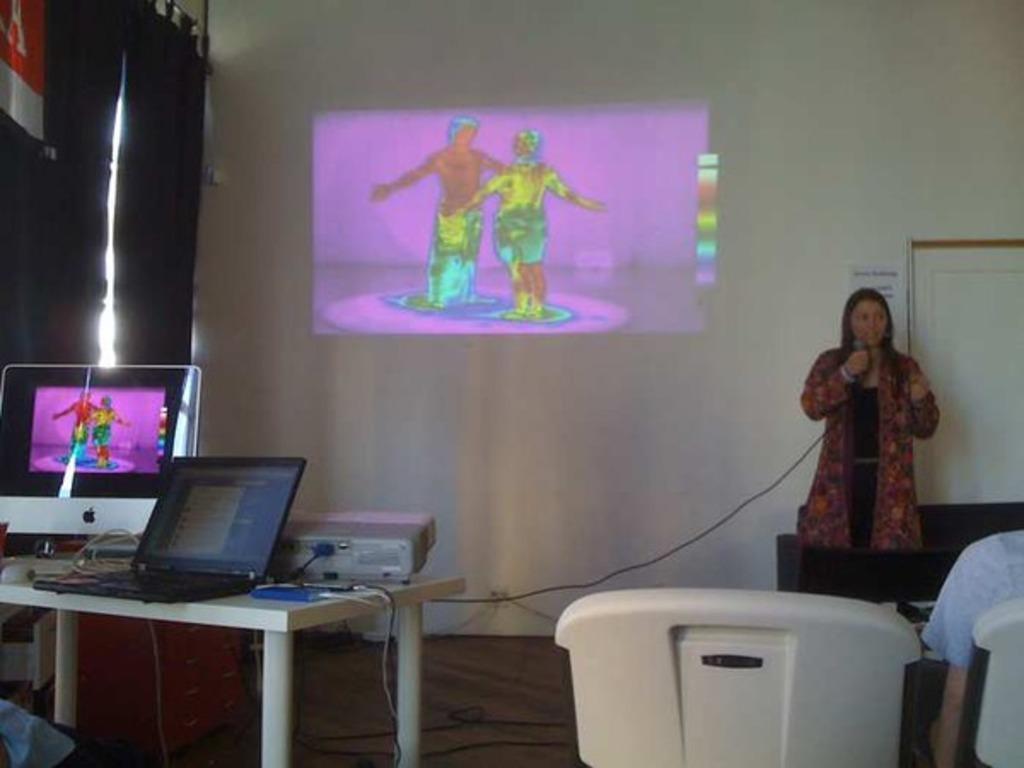Describe this image in one or two sentences. In the image there is a woman standing and speaking, there is a table on the left side and on the table there is a projector, laptop and a monitor. On the right side there are two chairs and there is a person sitting on the the chair, in the background there is a wall and on the wall some visuals are being displayed and beside the wall there are two curtains. 